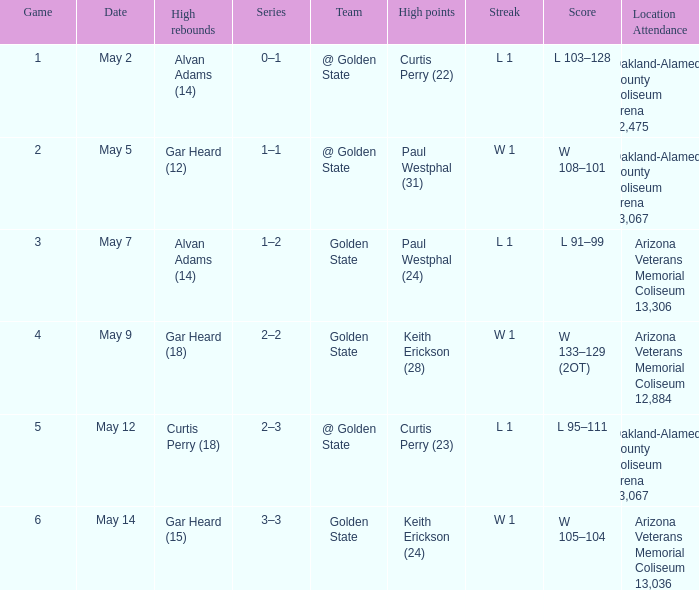How many games had they won or lost in a row on May 9? W 1. 